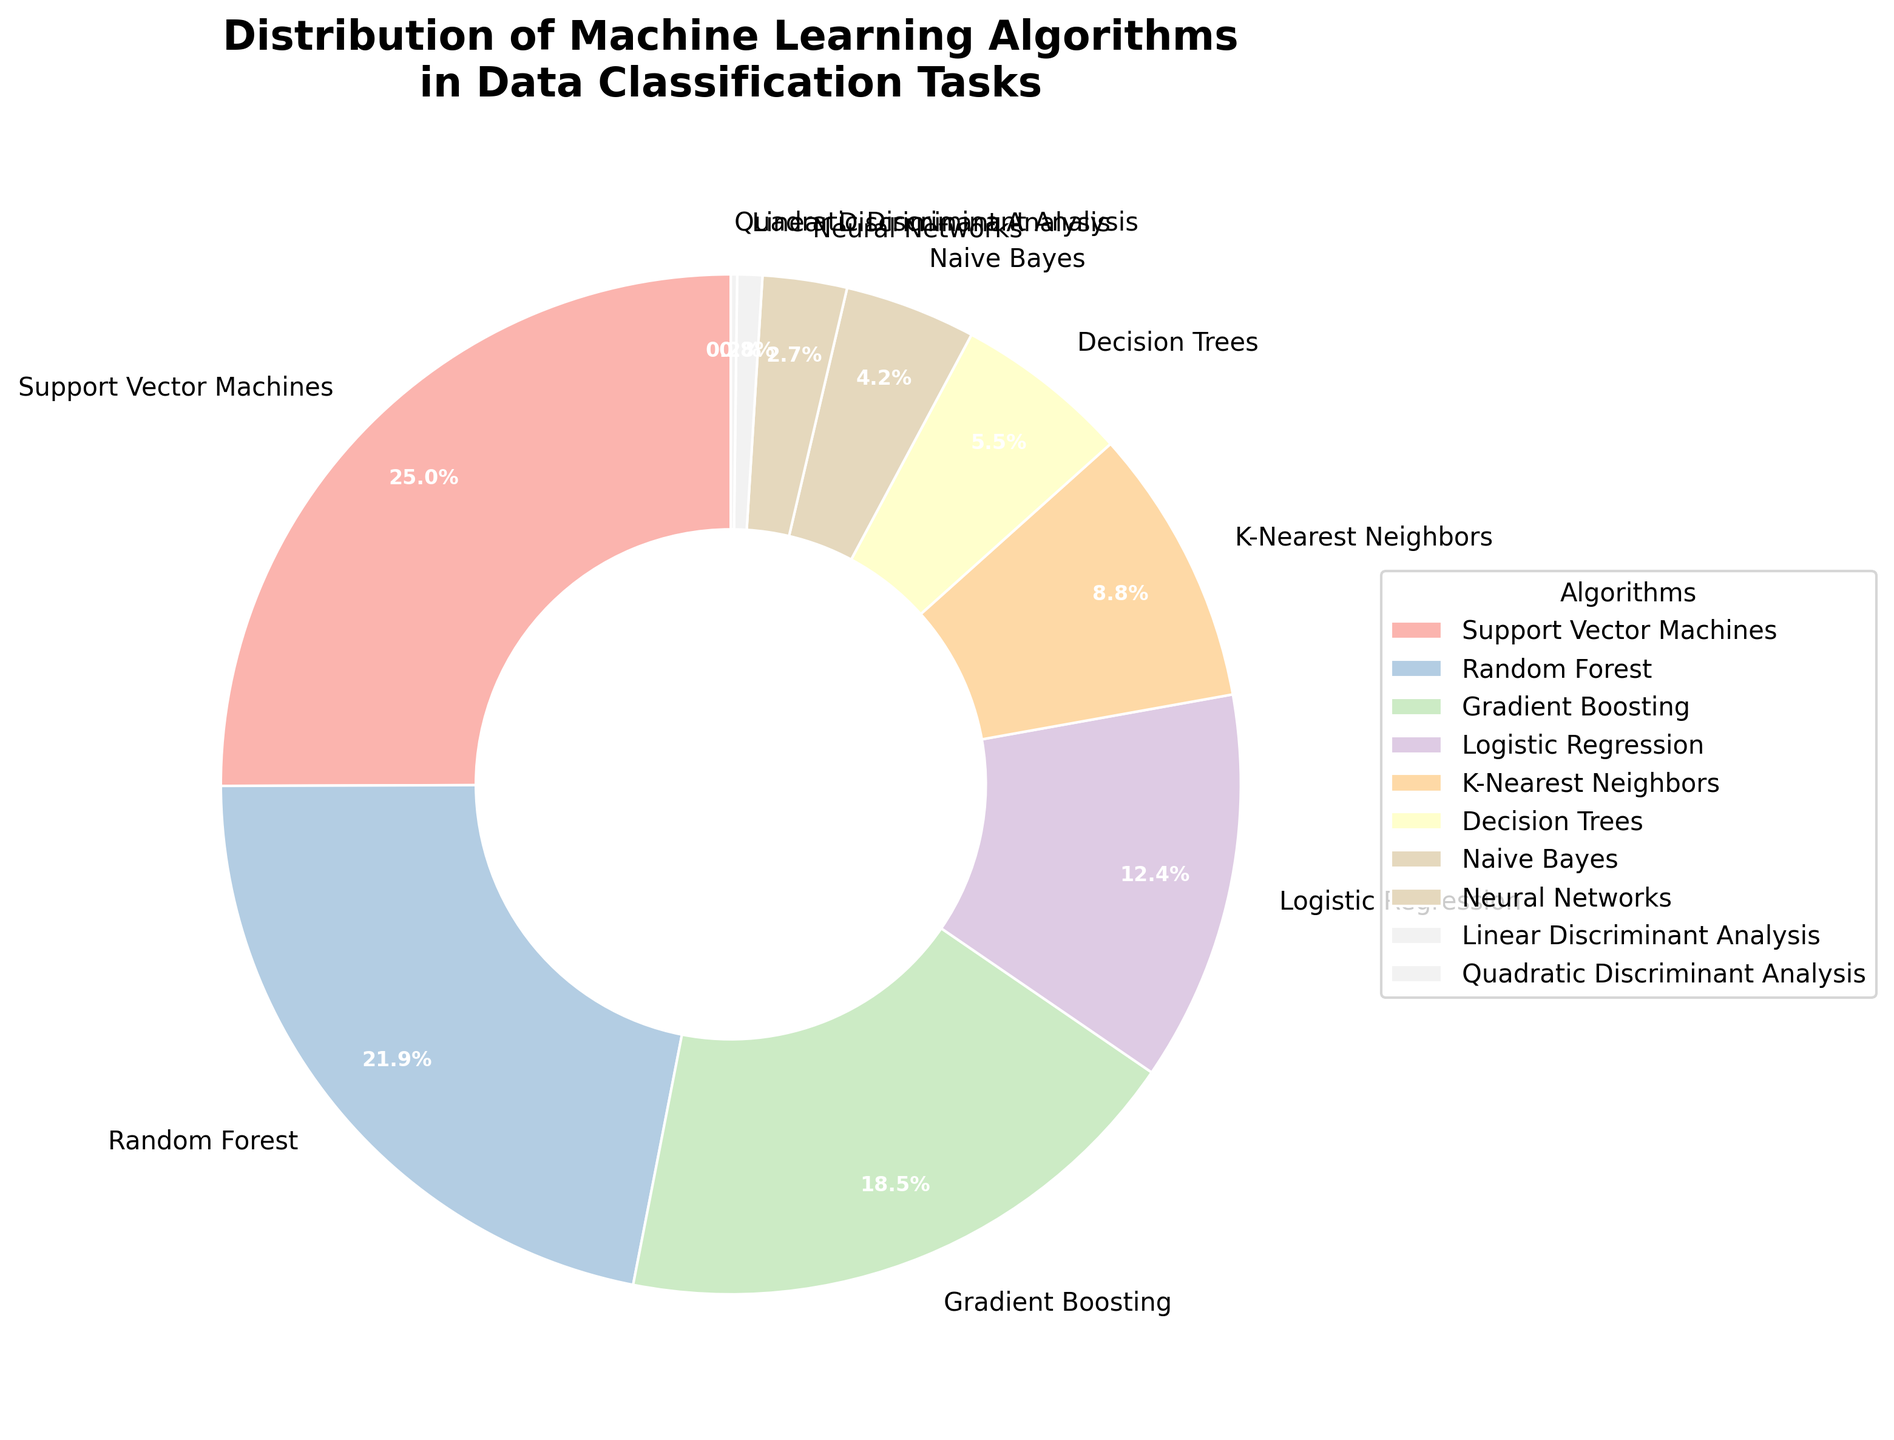Which algorithm is used the most for data classification tasks according to the pie chart? The pie chart shows that Support Vector Machines has the largest percentage, making it the most used algorithm for data classification tasks.
Answer: Support Vector Machines How many algorithms have a usage percentage above 20%? From the pie chart, Support Vector Machines (25.3%) and Random Forest (22.1%) have usage percentages above 20%.
Answer: 2 Which algorithm has the smallest usage percentage, and what is that percentage? The pie chart shows that Quadratic Discriminant Analysis has the smallest percentage at 0.2%.
Answer: Quadratic Discriminant Analysis, 0.2% What is the combined percentage of K-Nearest Neighbors, Naive Bayes, and Neural Networks? Adding the percentages: K-Nearest Neighbors (8.9%) + Naive Bayes (4.2%) + Neural Networks (2.7%) equals 15.8%.
Answer: 15.8% How much higher is the percentage of Gradient Boosting compared to Decision Trees? The percentage of Gradient Boosting is 18.7%, and Decision Trees is 5.6%. The difference is 18.7% - 5.6% = 13.1%.
Answer: 13.1% What is the average usage percentage of the top three most used algorithms? The top three most used algorithms are Support Vector Machines (25.3%), Random Forest (22.1%), and Gradient Boosting (18.7%). Adding these percentages and dividing by 3: (25.3 + 22.1 + 18.7) / 3 = 22.03%.
Answer: 22.03% Which two algorithms combined have a usage percentage lower than 1%? The pie chart shows Linear Discriminant Analysis (0.8%) and Quadratic Discriminant Analysis (0.2%) combined have a usage percentage of 0.8% + 0.2% = 1.0%. These are the only two algorithms with individual percentages below 1%.
Answer: Linear Discriminant Analysis and Quadratic Discriminant Analysis If the percentage of Logistic Regression increased by 5%, what would be the new percentage, and would it surpass Gradient Boosting? The current percentage for Logistic Regression is 12.5%. Adding 5% results in 12.5% + 5% = 17.5%. Gradient Boosting is 18.7%, so it would still be higher than Logistic Regression's new percentage of 17.5%.
Answer: 17.5%, no Is the percentage for Naive Bayes greater than, less than, or equal to the combined percentage of Decision Trees and Neural Networks? The percentage for Naive Bayes is 4.2%, while the combined percentage for Decision Trees (5.6%) and Neural Networks (2.7%) is 5.6% + 2.7% = 8.3%. Naive Bayes is less than the combined percentage of Decision Trees and Neural Networks.
Answer: less than What is the median percentage of the listed algorithms? The percentages arranged in ascending order are: 0.2, 0.8, 2.7, 4.2, 5.6, 8.9, 12.5, 18.7, 22.1, 25.3. The middle value is 8.9, making the median 8.9%.
Answer: 8.9% 